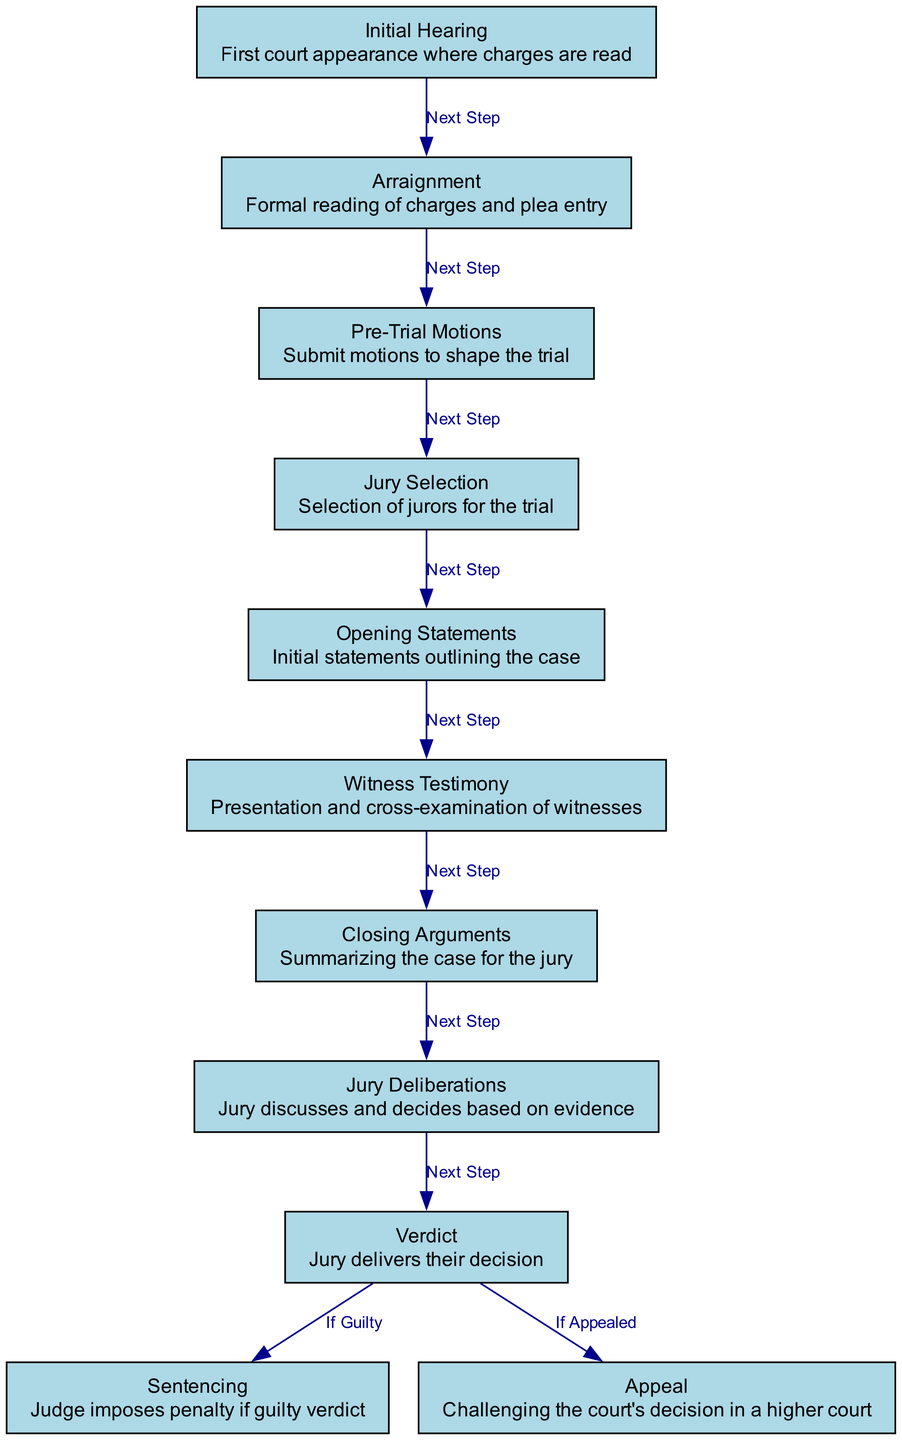What is the first step in the courtroom procedure? The diagram lists "Initial Hearing" as the first node, indicating that it is the starting point of the process where charges are read.
Answer: Initial Hearing How many nodes are present in the diagram? By counting the unique steps in the diagram, there are a total of 11 distinct nodes listed, representing different stages of the courtroom procedure.
Answer: 11 What follows the Arraignment in the courtroom process? The diagram shows an edge labeled "Next Step" leading from "Arraignment" to "Pre-Trial Motions," indicating that Pre-Trial Motions is the subsequent step.
Answer: Pre-Trial Motions What is the function of jury deliberation according to the diagram? The diagram describes "Jury Deliberations" as the stage where the jury discusses and decides based on evidence, highlighting its critical role in reaching a verdict.
Answer: Discuss and decide Which step comes immediately before the verdict? Analyzing the diagram, "Jury Deliberation" directly precedes "Verdict," as indicated by the edge connecting them.
Answer: Jury Deliberation What happens if a guilty verdict is reached? The diagram indicates that when a guilty verdict is delivered, the next step is "Sentencing," according to the edge labeled "If Guilty."
Answer: Sentencing What type of motion can be submitted during the pre-trial stage? The "Pre-Trial Motions" node in the diagram specifies that various motions can be submitted to shape the trial, involving requests made before the trial formally begins.
Answer: Motions What is the last step in the process if an appeal is filed? The diagram states that if a verdict is appealed, the final stage to follow is "Appeal," which implies challenging the court's decision in a higher court.
Answer: Appeal How does the opening statement relate to witness testimony? The diagram illustrates that "Opening Statements" precede "Witness Testimony," indicating that initial case presentations are made before witness evidence is presented.
Answer: Opening Statements 